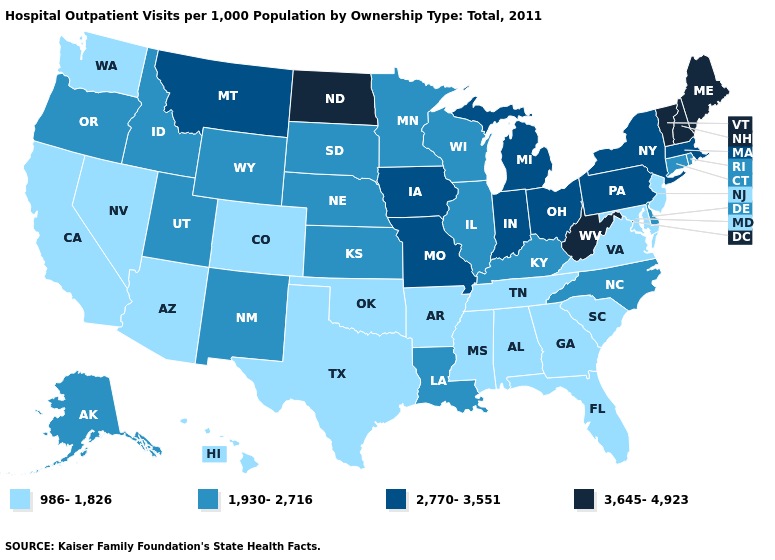What is the value of Missouri?
Quick response, please. 2,770-3,551. What is the value of Kansas?
Concise answer only. 1,930-2,716. Name the states that have a value in the range 2,770-3,551?
Answer briefly. Indiana, Iowa, Massachusetts, Michigan, Missouri, Montana, New York, Ohio, Pennsylvania. What is the highest value in states that border West Virginia?
Keep it brief. 2,770-3,551. Among the states that border New Mexico , which have the lowest value?
Keep it brief. Arizona, Colorado, Oklahoma, Texas. Does Michigan have a lower value than Vermont?
Be succinct. Yes. What is the highest value in the MidWest ?
Give a very brief answer. 3,645-4,923. Does Arkansas have the lowest value in the South?
Be succinct. Yes. Name the states that have a value in the range 2,770-3,551?
Keep it brief. Indiana, Iowa, Massachusetts, Michigan, Missouri, Montana, New York, Ohio, Pennsylvania. What is the highest value in states that border North Carolina?
Be succinct. 986-1,826. What is the value of Nebraska?
Be succinct. 1,930-2,716. What is the value of Iowa?
Answer briefly. 2,770-3,551. Name the states that have a value in the range 2,770-3,551?
Quick response, please. Indiana, Iowa, Massachusetts, Michigan, Missouri, Montana, New York, Ohio, Pennsylvania. Name the states that have a value in the range 3,645-4,923?
Short answer required. Maine, New Hampshire, North Dakota, Vermont, West Virginia. 